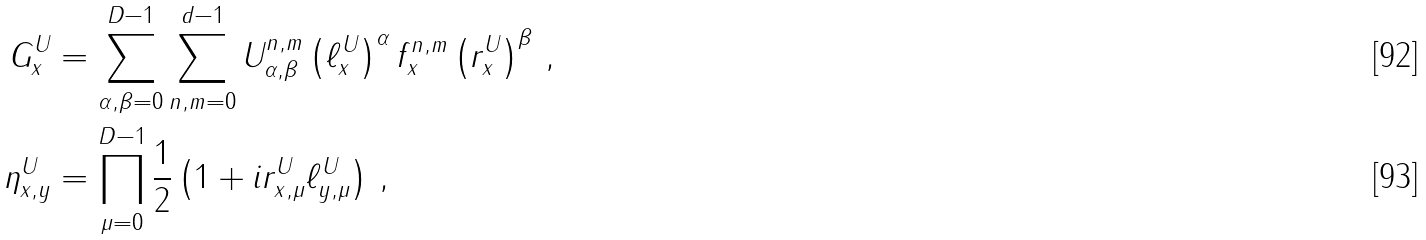<formula> <loc_0><loc_0><loc_500><loc_500>G ^ { U } _ { x } & = \sum _ { \alpha , \beta = 0 } ^ { D - 1 } \sum _ { n , m = 0 } ^ { d - 1 } U _ { \alpha , \beta } ^ { n , m } \left ( \ell _ { x } ^ { U } \right ) ^ { \alpha } f _ { x } ^ { n , m } \left ( r ^ { U } _ { x } \right ) ^ { \beta } \, , \\ \eta ^ { U } _ { x , y } & = \prod _ { \mu = 0 } ^ { D - 1 } \frac { 1 } { 2 } \left ( 1 + i r ^ { U } _ { x , \mu } \ell ^ { U } _ { y , \mu } \right ) \, ,</formula> 